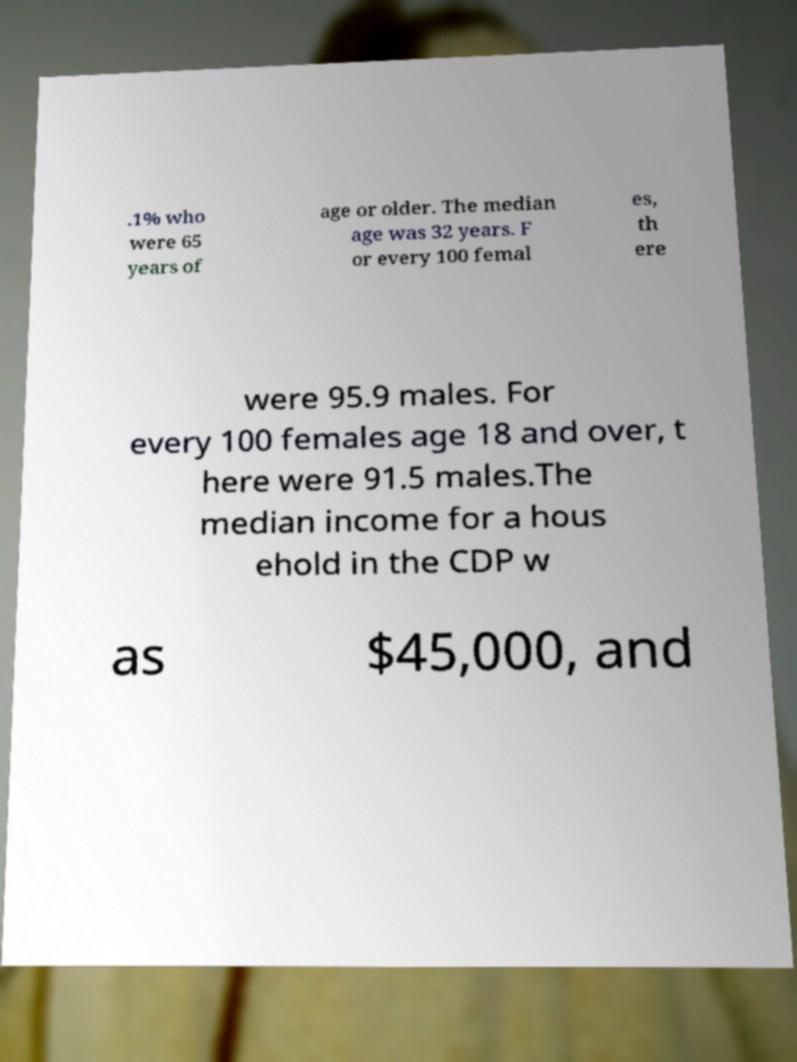I need the written content from this picture converted into text. Can you do that? .1% who were 65 years of age or older. The median age was 32 years. F or every 100 femal es, th ere were 95.9 males. For every 100 females age 18 and over, t here were 91.5 males.The median income for a hous ehold in the CDP w as $45,000, and 